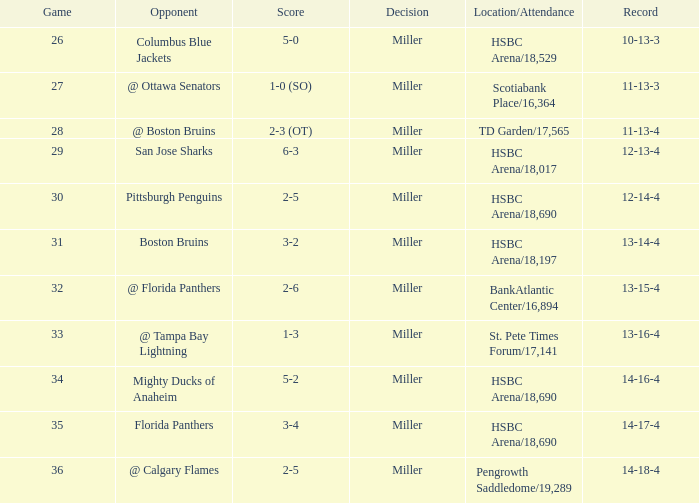Name the opponent for record 10-13-3 Columbus Blue Jackets. 